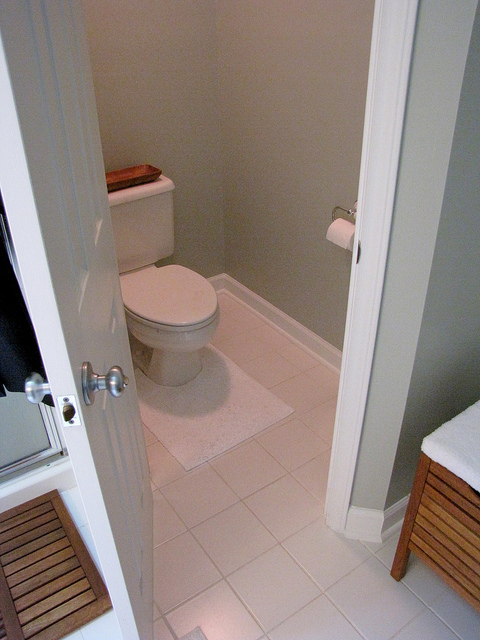<image>What color is dominant? I am not sure the dominant color. It can be white, pink or green. What color is dominant? I don't know what color is dominant. It can be either white, pink or green. 